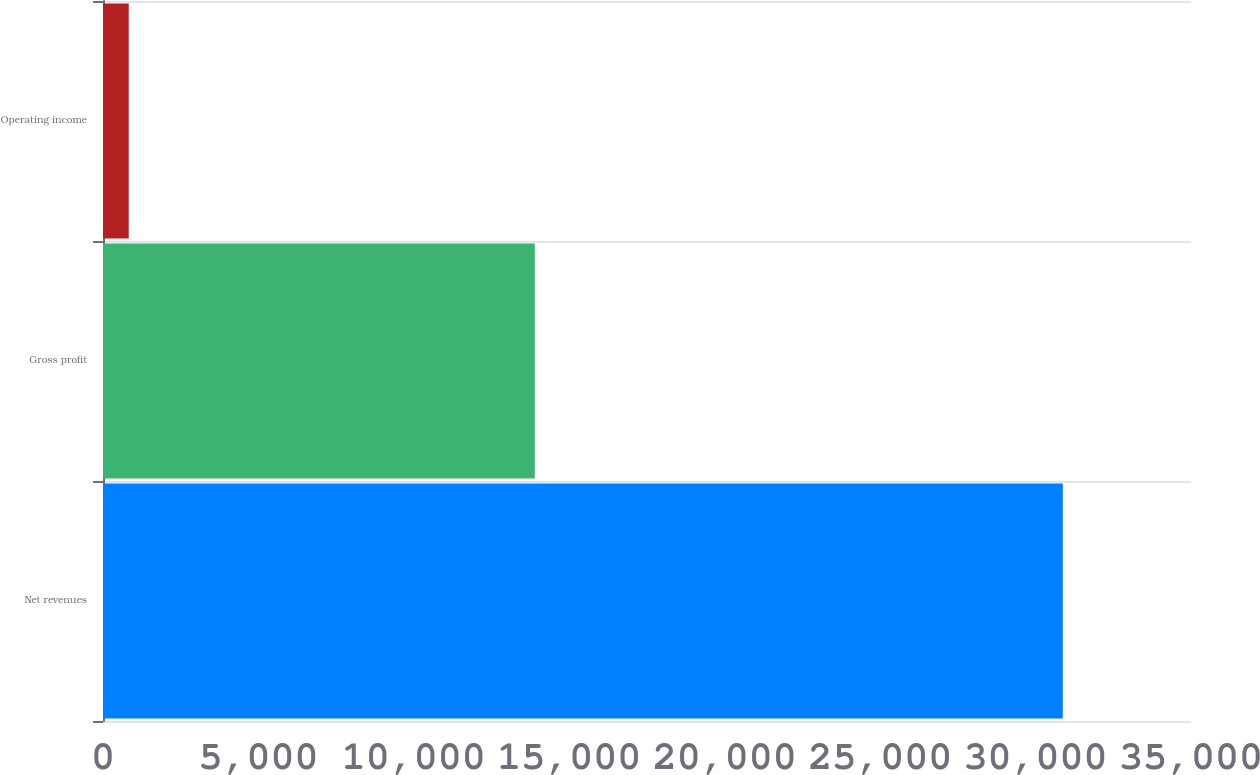Convert chart to OTSL. <chart><loc_0><loc_0><loc_500><loc_500><bar_chart><fcel>Net revenues<fcel>Gross profit<fcel>Operating income<nl><fcel>30876<fcel>13891<fcel>828<nl></chart> 